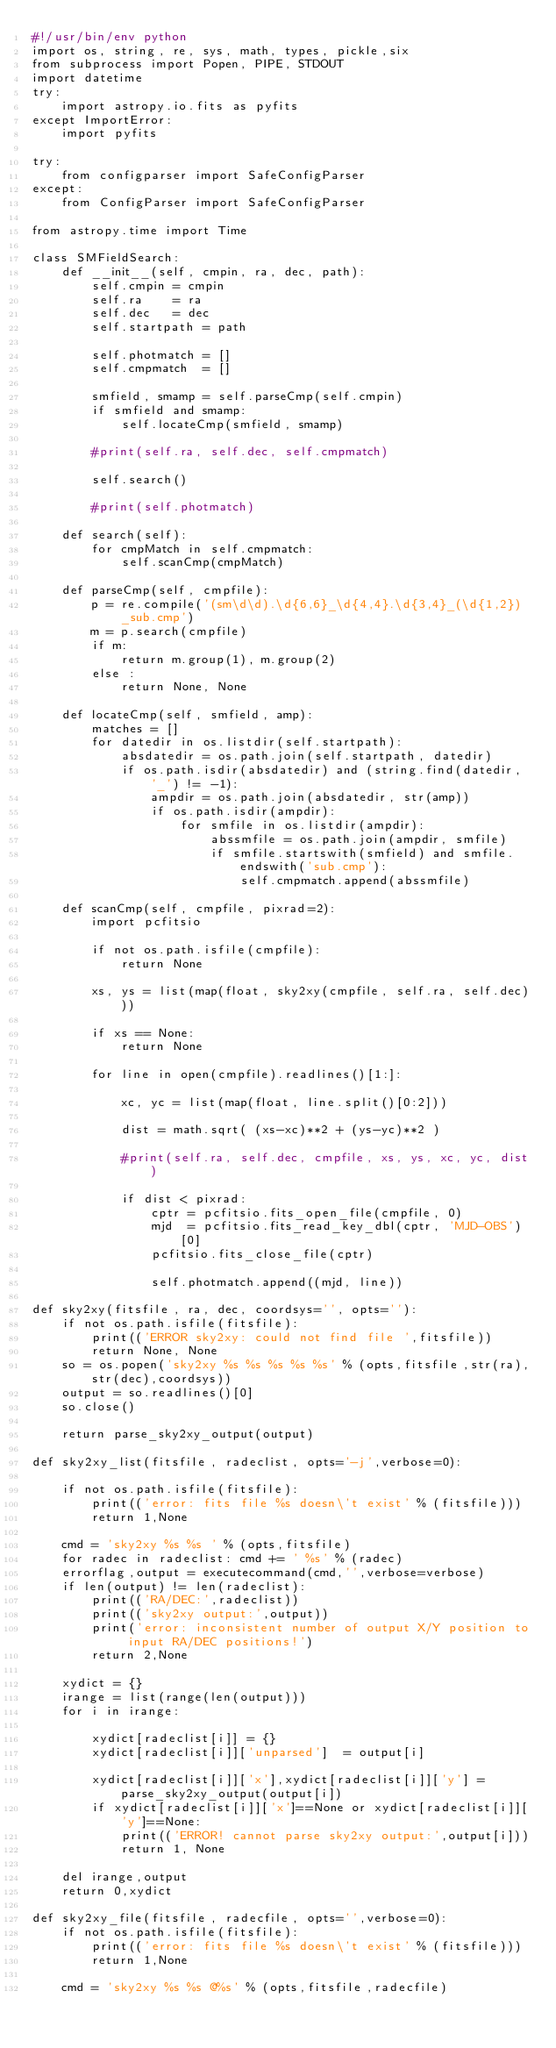Convert code to text. <code><loc_0><loc_0><loc_500><loc_500><_Python_>#!/usr/bin/env python
import os, string, re, sys, math, types, pickle,six
from subprocess import Popen, PIPE, STDOUT
import datetime
try:
    import astropy.io.fits as pyfits
except ImportError:
    import pyfits
    
try: 
    from configparser import SafeConfigParser
except:
    from ConfigParser import SafeConfigParser

from astropy.time import Time

class SMFieldSearch:
    def __init__(self, cmpin, ra, dec, path):
        self.cmpin = cmpin
        self.ra    = ra
        self.dec   = dec
        self.startpath = path

        self.photmatch = []
        self.cmpmatch  = []

        smfield, smamp = self.parseCmp(self.cmpin)
        if smfield and smamp:
            self.locateCmp(smfield, smamp)

        #print(self.ra, self.dec, self.cmpmatch)

        self.search()

        #print(self.photmatch)

    def search(self):
        for cmpMatch in self.cmpmatch:
            self.scanCmp(cmpMatch)

    def parseCmp(self, cmpfile):
        p = re.compile('(sm\d\d).\d{6,6}_\d{4,4}.\d{3,4}_(\d{1,2})_sub.cmp')
        m = p.search(cmpfile)
        if m:
            return m.group(1), m.group(2)
        else :
            return None, None

    def locateCmp(self, smfield, amp):
        matches = []
        for datedir in os.listdir(self.startpath):
            absdatedir = os.path.join(self.startpath, datedir)
            if os.path.isdir(absdatedir) and (string.find(datedir, '_') != -1):
                ampdir = os.path.join(absdatedir, str(amp))
                if os.path.isdir(ampdir):
                    for smfile in os.listdir(ampdir):
                        abssmfile = os.path.join(ampdir, smfile)
                        if smfile.startswith(smfield) and smfile.endswith('sub.cmp'):
                            self.cmpmatch.append(abssmfile)

    def scanCmp(self, cmpfile, pixrad=2):
        import pcfitsio

        if not os.path.isfile(cmpfile):
            return None

        xs, ys = list(map(float, sky2xy(cmpfile, self.ra, self.dec)))

        if xs == None:
            return None

        for line in open(cmpfile).readlines()[1:]:

            xc, yc = list(map(float, line.split()[0:2]))

            dist = math.sqrt( (xs-xc)**2 + (ys-yc)**2 )

            #print(self.ra, self.dec, cmpfile, xs, ys, xc, yc, dist)

            if dist < pixrad:
                cptr = pcfitsio.fits_open_file(cmpfile, 0)
                mjd  = pcfitsio.fits_read_key_dbl(cptr, 'MJD-OBS')[0]
                pcfitsio.fits_close_file(cptr)

                self.photmatch.append((mjd, line))

def sky2xy(fitsfile, ra, dec, coordsys='', opts=''):
    if not os.path.isfile(fitsfile):
        print(('ERROR sky2xy: could not find file ',fitsfile))
        return None, None
    so = os.popen('sky2xy %s %s %s %s %s' % (opts,fitsfile,str(ra),str(dec),coordsys))
    output = so.readlines()[0]
    so.close()

    return parse_sky2xy_output(output)

def sky2xy_list(fitsfile, radeclist, opts='-j',verbose=0):

    if not os.path.isfile(fitsfile):
        print(('error: fits file %s doesn\'t exist' % (fitsfile)))
        return 1,None

    cmd = 'sky2xy %s %s ' % (opts,fitsfile)
    for radec in radeclist: cmd += ' %s' % (radec)
    errorflag,output = executecommand(cmd,'',verbose=verbose)
    if len(output) != len(radeclist):
        print(('RA/DEC:',radeclist))
        print(('sky2xy output:',output))
        print('error: inconsistent number of output X/Y position to input RA/DEC positions!')
        return 2,None

    xydict = {}
    irange = list(range(len(output)))
    for i in irange:

        xydict[radeclist[i]] = {}
        xydict[radeclist[i]]['unparsed']  = output[i]

        xydict[radeclist[i]]['x'],xydict[radeclist[i]]['y'] = parse_sky2xy_output(output[i])
        if xydict[radeclist[i]]['x']==None or xydict[radeclist[i]]['y']==None:
            print(('ERROR! cannot parse sky2xy output:',output[i]))
            return 1, None

    del irange,output
    return 0,xydict

def sky2xy_file(fitsfile, radecfile, opts='',verbose=0):
    if not os.path.isfile(fitsfile):
        print(('error: fits file %s doesn\'t exist' % (fitsfile)))
        return 1,None

    cmd = 'sky2xy %s %s @%s' % (opts,fitsfile,radecfile)</code> 